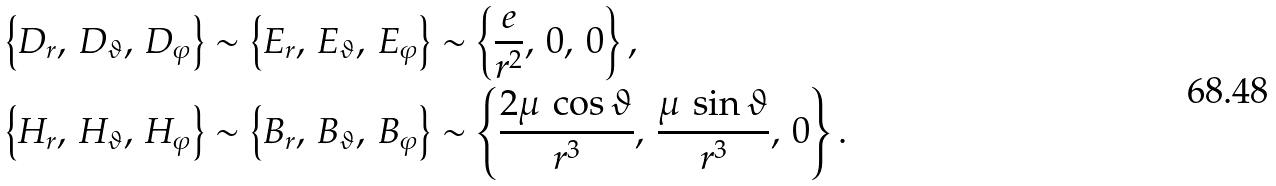<formula> <loc_0><loc_0><loc_500><loc_500>\left \{ D _ { r } , \, D _ { \vartheta } , \, D _ { \varphi } \right \} \sim \left \{ E _ { r } , \, E _ { \vartheta } , \, E _ { \varphi } \right \} & \sim \left \{ \frac { e } { r ^ { 2 } } , \, 0 , \, 0 \right \} , \\ \left \{ H _ { r } , \, H _ { \vartheta } , \, H _ { \varphi } \right \} \sim \left \{ B _ { r } , \, B _ { \vartheta } , \, B _ { \varphi } \right \} & \sim \left \{ \frac { 2 \mu \, \cos \vartheta } { r ^ { 3 } } , \, \frac { \mu \, \sin \vartheta } { r ^ { 3 } } , \, 0 \right \} .</formula> 